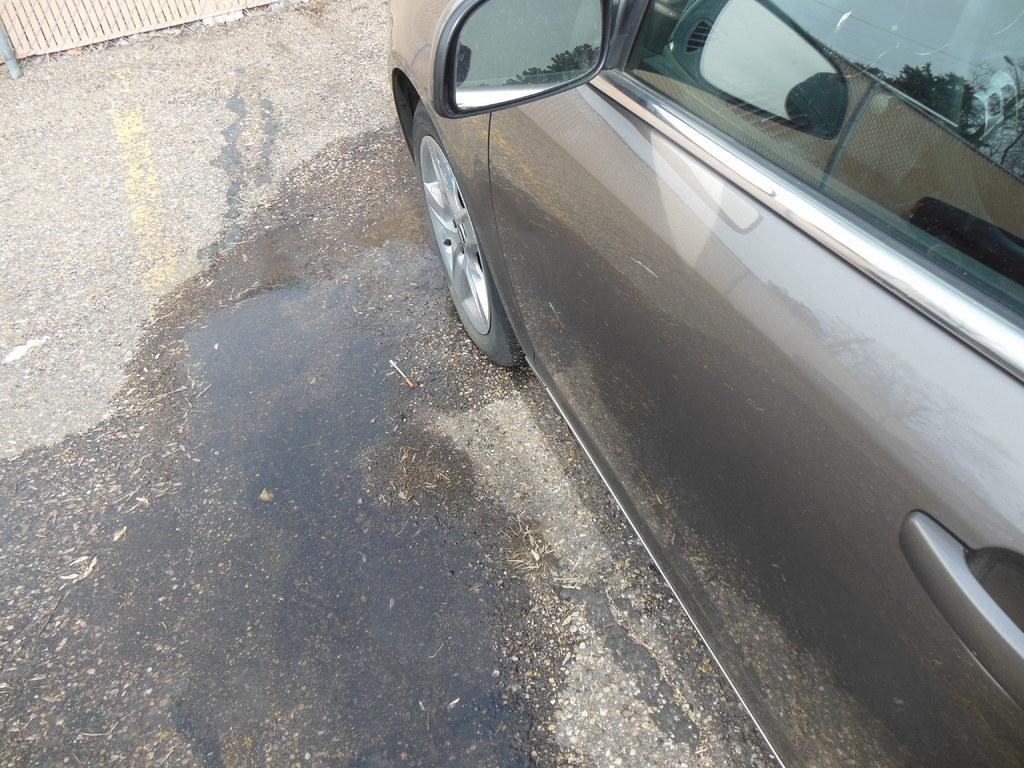What is the main subject of the image? The main subject of the image is a car. Where is the car located in the image? The car is on a road in the image. How is the car positioned in the image? The car is in the center of the image. What type of steel is used to manufacture the car in the image? There is no information about the type of steel used to manufacture the car in the image. How does the car's distribution system work in the image? The image does not provide information about the car's distribution system. 